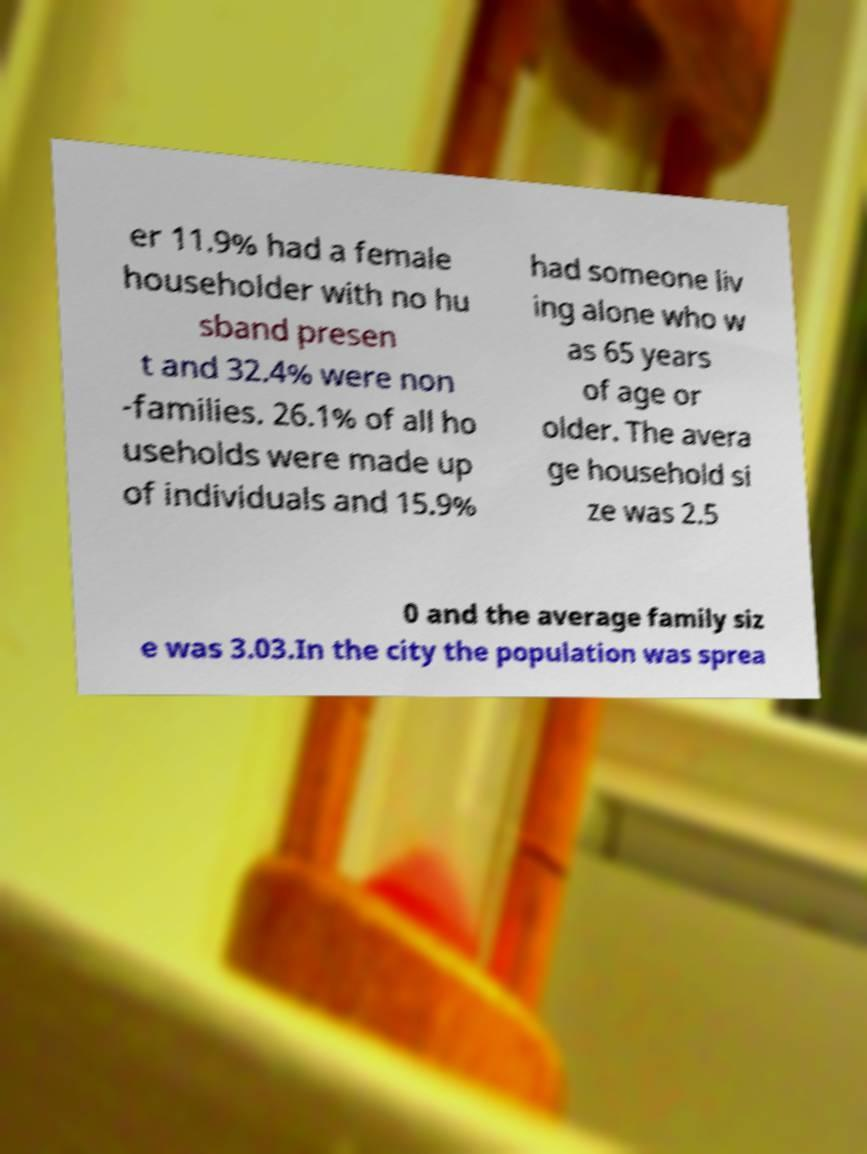Can you read and provide the text displayed in the image?This photo seems to have some interesting text. Can you extract and type it out for me? er 11.9% had a female householder with no hu sband presen t and 32.4% were non -families. 26.1% of all ho useholds were made up of individuals and 15.9% had someone liv ing alone who w as 65 years of age or older. The avera ge household si ze was 2.5 0 and the average family siz e was 3.03.In the city the population was sprea 